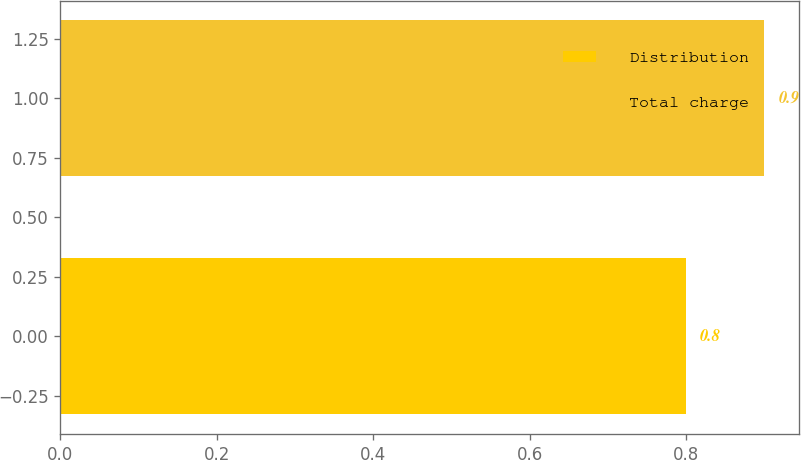Convert chart. <chart><loc_0><loc_0><loc_500><loc_500><bar_chart><fcel>Distribution<fcel>Total charge<nl><fcel>0.8<fcel>0.9<nl></chart> 